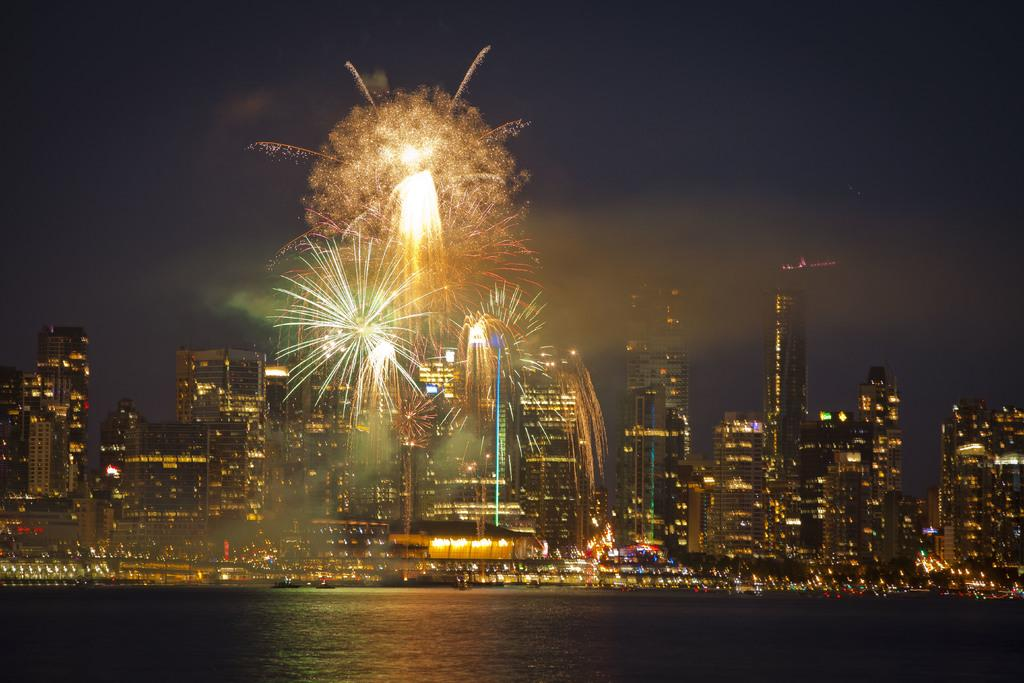What type of structures can be seen in the background of the image? There are buildings in the background of the image. What feature do the buildings have? The buildings have lights. What natural feature is present in the image? There is a lake in the image. Where is the faucet located in the image? There is no faucet present in the image. What type of line can be seen connecting the buildings in the image? There is no line connecting the buildings in the image. 